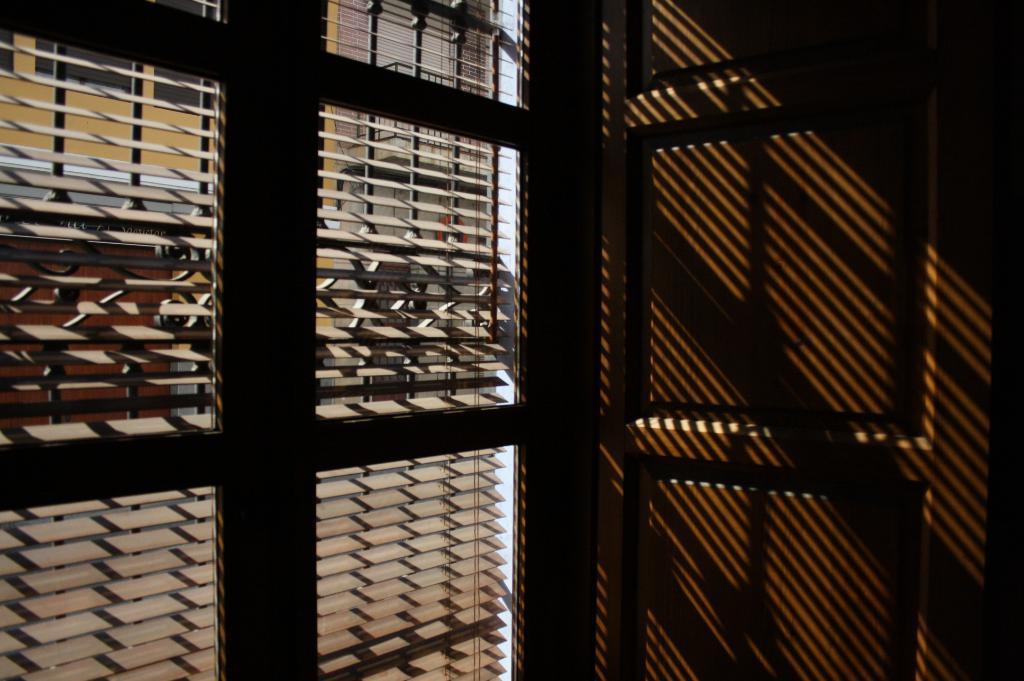Please provide a concise description of this image. In this picture we can see a window, door and through this window we can see a building and some objects. 